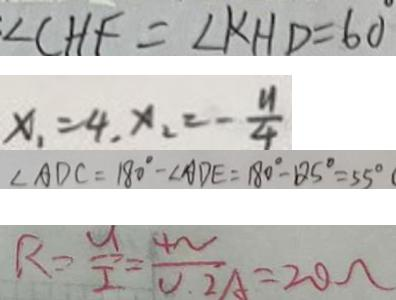Convert formula to latex. <formula><loc_0><loc_0><loc_500><loc_500>\angle C H F = \angle K H D = 6 0 
 x _ { 1 } = 4 , x _ { 2 } = - \frac { y } { 4 } 
 \angle A D C = 1 8 0 ^ { \circ } - \angle A D E = 1 8 0 ^ { \circ } - 1 2 5 ^ { \circ } = 5 5 ^ { \circ } 
 R = \frac { U } { I } = \frac { 4 N } { 0 . 2 A } = 2 0 \Omega</formula> 